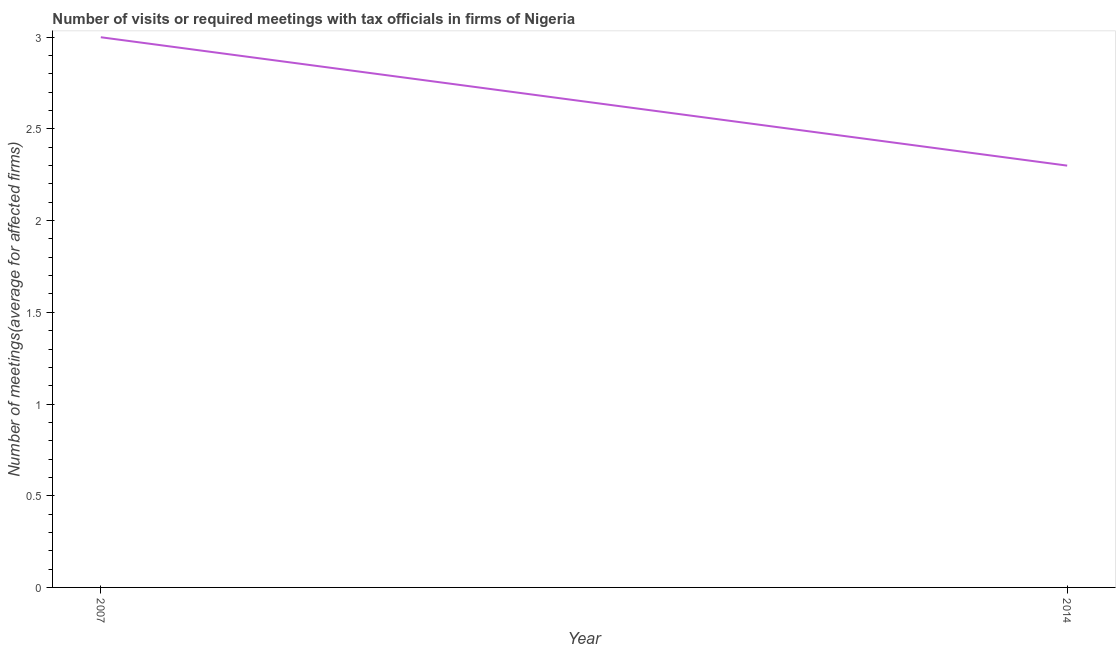Across all years, what is the maximum number of required meetings with tax officials?
Provide a succinct answer. 3. In which year was the number of required meetings with tax officials minimum?
Offer a very short reply. 2014. What is the difference between the number of required meetings with tax officials in 2007 and 2014?
Offer a terse response. 0.7. What is the average number of required meetings with tax officials per year?
Offer a very short reply. 2.65. What is the median number of required meetings with tax officials?
Make the answer very short. 2.65. In how many years, is the number of required meetings with tax officials greater than 1.9 ?
Provide a succinct answer. 2. What is the ratio of the number of required meetings with tax officials in 2007 to that in 2014?
Your answer should be very brief. 1.3. Is the number of required meetings with tax officials in 2007 less than that in 2014?
Provide a succinct answer. No. In how many years, is the number of required meetings with tax officials greater than the average number of required meetings with tax officials taken over all years?
Keep it short and to the point. 1. Does the number of required meetings with tax officials monotonically increase over the years?
Provide a short and direct response. No. How many lines are there?
Your response must be concise. 1. What is the difference between two consecutive major ticks on the Y-axis?
Keep it short and to the point. 0.5. Does the graph contain grids?
Your answer should be compact. No. What is the title of the graph?
Provide a succinct answer. Number of visits or required meetings with tax officials in firms of Nigeria. What is the label or title of the X-axis?
Provide a short and direct response. Year. What is the label or title of the Y-axis?
Offer a very short reply. Number of meetings(average for affected firms). What is the Number of meetings(average for affected firms) of 2007?
Offer a terse response. 3. What is the difference between the Number of meetings(average for affected firms) in 2007 and 2014?
Offer a very short reply. 0.7. What is the ratio of the Number of meetings(average for affected firms) in 2007 to that in 2014?
Provide a succinct answer. 1.3. 